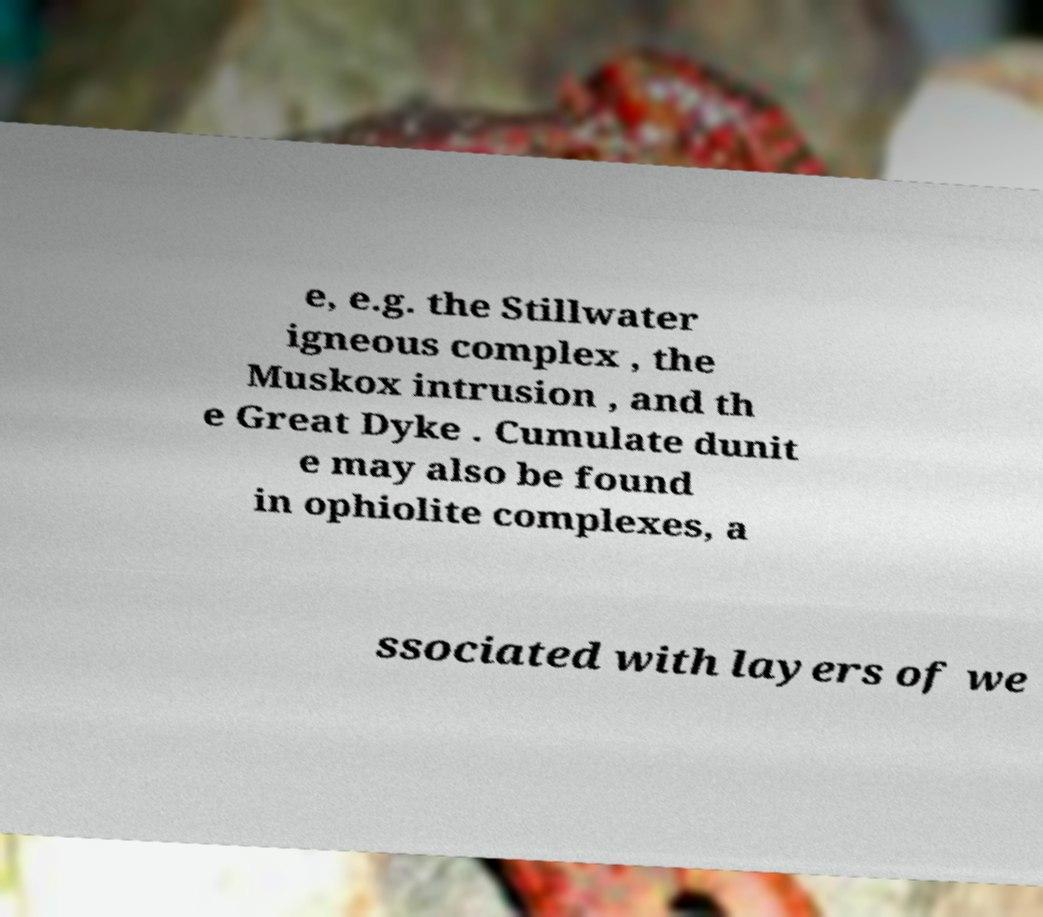Could you assist in decoding the text presented in this image and type it out clearly? e, e.g. the Stillwater igneous complex , the Muskox intrusion , and th e Great Dyke . Cumulate dunit e may also be found in ophiolite complexes, a ssociated with layers of we 